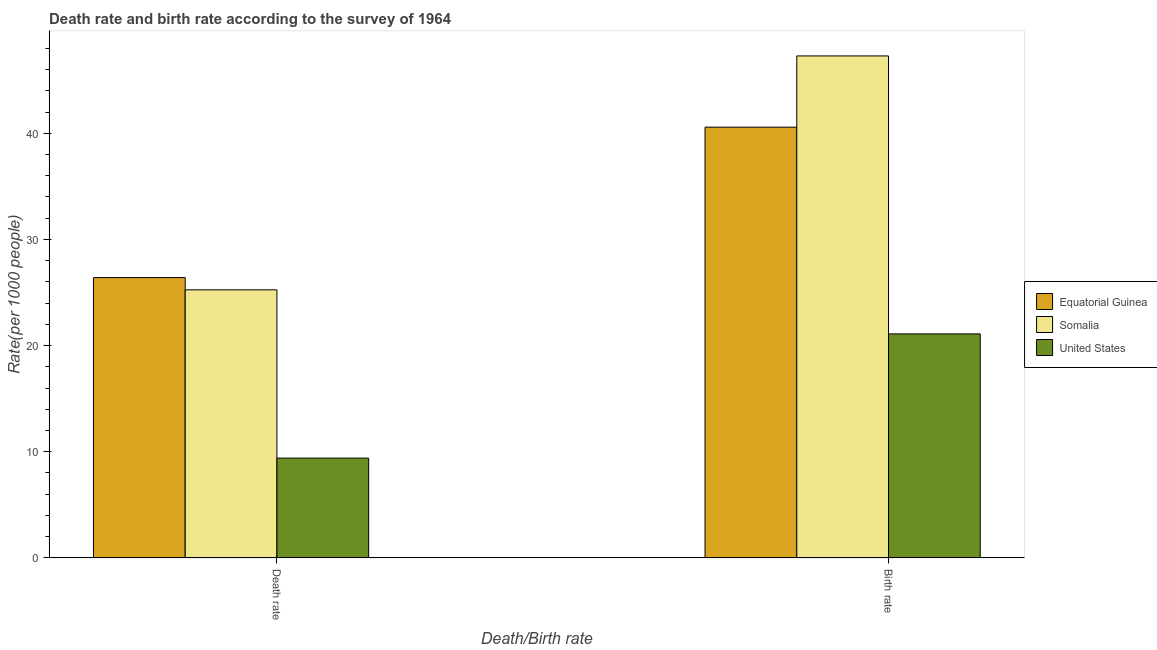How many different coloured bars are there?
Provide a short and direct response. 3. How many groups of bars are there?
Give a very brief answer. 2. Are the number of bars per tick equal to the number of legend labels?
Offer a terse response. Yes. What is the label of the 1st group of bars from the left?
Provide a short and direct response. Death rate. What is the birth rate in Equatorial Guinea?
Keep it short and to the point. 40.57. Across all countries, what is the maximum birth rate?
Keep it short and to the point. 47.28. Across all countries, what is the minimum birth rate?
Offer a terse response. 21.1. In which country was the birth rate maximum?
Provide a succinct answer. Somalia. What is the total death rate in the graph?
Your response must be concise. 61.05. What is the difference between the birth rate in Somalia and that in Equatorial Guinea?
Your answer should be very brief. 6.71. What is the difference between the death rate in Equatorial Guinea and the birth rate in United States?
Give a very brief answer. 5.3. What is the average birth rate per country?
Make the answer very short. 36.32. What is the difference between the birth rate and death rate in Equatorial Guinea?
Provide a succinct answer. 14.17. In how many countries, is the birth rate greater than 34 ?
Your answer should be very brief. 2. What is the ratio of the birth rate in Somalia to that in United States?
Keep it short and to the point. 2.24. Is the birth rate in Somalia less than that in United States?
Offer a very short reply. No. In how many countries, is the death rate greater than the average death rate taken over all countries?
Ensure brevity in your answer.  2. What does the 1st bar from the left in Death rate represents?
Your answer should be compact. Equatorial Guinea. What does the 2nd bar from the right in Death rate represents?
Keep it short and to the point. Somalia. How many bars are there?
Provide a succinct answer. 6. Does the graph contain any zero values?
Give a very brief answer. No. Where does the legend appear in the graph?
Offer a terse response. Center right. What is the title of the graph?
Your answer should be very brief. Death rate and birth rate according to the survey of 1964. What is the label or title of the X-axis?
Provide a succinct answer. Death/Birth rate. What is the label or title of the Y-axis?
Offer a terse response. Rate(per 1000 people). What is the Rate(per 1000 people) of Equatorial Guinea in Death rate?
Your answer should be very brief. 26.4. What is the Rate(per 1000 people) of Somalia in Death rate?
Keep it short and to the point. 25.25. What is the Rate(per 1000 people) of United States in Death rate?
Make the answer very short. 9.4. What is the Rate(per 1000 people) of Equatorial Guinea in Birth rate?
Your answer should be very brief. 40.57. What is the Rate(per 1000 people) of Somalia in Birth rate?
Provide a short and direct response. 47.28. What is the Rate(per 1000 people) of United States in Birth rate?
Your answer should be very brief. 21.1. Across all Death/Birth rate, what is the maximum Rate(per 1000 people) of Equatorial Guinea?
Ensure brevity in your answer.  40.57. Across all Death/Birth rate, what is the maximum Rate(per 1000 people) in Somalia?
Your answer should be very brief. 47.28. Across all Death/Birth rate, what is the maximum Rate(per 1000 people) of United States?
Make the answer very short. 21.1. Across all Death/Birth rate, what is the minimum Rate(per 1000 people) of Equatorial Guinea?
Your answer should be compact. 26.4. Across all Death/Birth rate, what is the minimum Rate(per 1000 people) in Somalia?
Provide a succinct answer. 25.25. Across all Death/Birth rate, what is the minimum Rate(per 1000 people) of United States?
Your answer should be compact. 9.4. What is the total Rate(per 1000 people) of Equatorial Guinea in the graph?
Keep it short and to the point. 66.98. What is the total Rate(per 1000 people) in Somalia in the graph?
Provide a short and direct response. 72.53. What is the total Rate(per 1000 people) in United States in the graph?
Your response must be concise. 30.5. What is the difference between the Rate(per 1000 people) in Equatorial Guinea in Death rate and that in Birth rate?
Offer a terse response. -14.17. What is the difference between the Rate(per 1000 people) in Somalia in Death rate and that in Birth rate?
Offer a very short reply. -22.03. What is the difference between the Rate(per 1000 people) of Equatorial Guinea in Death rate and the Rate(per 1000 people) of Somalia in Birth rate?
Provide a short and direct response. -20.88. What is the difference between the Rate(per 1000 people) in Equatorial Guinea in Death rate and the Rate(per 1000 people) in United States in Birth rate?
Your answer should be compact. 5.3. What is the difference between the Rate(per 1000 people) in Somalia in Death rate and the Rate(per 1000 people) in United States in Birth rate?
Your response must be concise. 4.15. What is the average Rate(per 1000 people) in Equatorial Guinea per Death/Birth rate?
Ensure brevity in your answer.  33.49. What is the average Rate(per 1000 people) of Somalia per Death/Birth rate?
Your answer should be very brief. 36.27. What is the average Rate(per 1000 people) in United States per Death/Birth rate?
Make the answer very short. 15.25. What is the difference between the Rate(per 1000 people) of Equatorial Guinea and Rate(per 1000 people) of Somalia in Death rate?
Provide a short and direct response. 1.15. What is the difference between the Rate(per 1000 people) in Equatorial Guinea and Rate(per 1000 people) in United States in Death rate?
Your answer should be compact. 17. What is the difference between the Rate(per 1000 people) in Somalia and Rate(per 1000 people) in United States in Death rate?
Your response must be concise. 15.85. What is the difference between the Rate(per 1000 people) in Equatorial Guinea and Rate(per 1000 people) in Somalia in Birth rate?
Offer a terse response. -6.71. What is the difference between the Rate(per 1000 people) of Equatorial Guinea and Rate(per 1000 people) of United States in Birth rate?
Provide a short and direct response. 19.47. What is the difference between the Rate(per 1000 people) in Somalia and Rate(per 1000 people) in United States in Birth rate?
Make the answer very short. 26.18. What is the ratio of the Rate(per 1000 people) in Equatorial Guinea in Death rate to that in Birth rate?
Your response must be concise. 0.65. What is the ratio of the Rate(per 1000 people) in Somalia in Death rate to that in Birth rate?
Make the answer very short. 0.53. What is the ratio of the Rate(per 1000 people) in United States in Death rate to that in Birth rate?
Your answer should be compact. 0.45. What is the difference between the highest and the second highest Rate(per 1000 people) in Equatorial Guinea?
Your answer should be compact. 14.17. What is the difference between the highest and the second highest Rate(per 1000 people) of Somalia?
Provide a succinct answer. 22.03. What is the difference between the highest and the second highest Rate(per 1000 people) in United States?
Offer a very short reply. 11.7. What is the difference between the highest and the lowest Rate(per 1000 people) of Equatorial Guinea?
Your answer should be compact. 14.17. What is the difference between the highest and the lowest Rate(per 1000 people) of Somalia?
Offer a terse response. 22.03. 